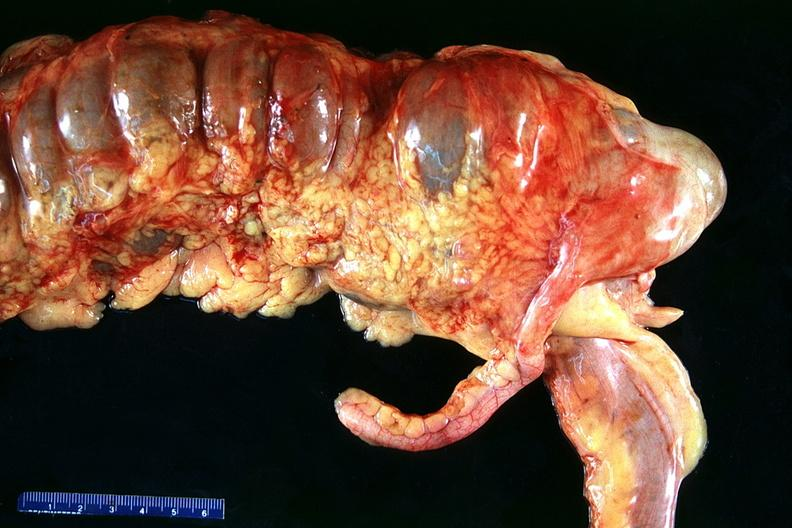does yo show normal appendix?
Answer the question using a single word or phrase. No 